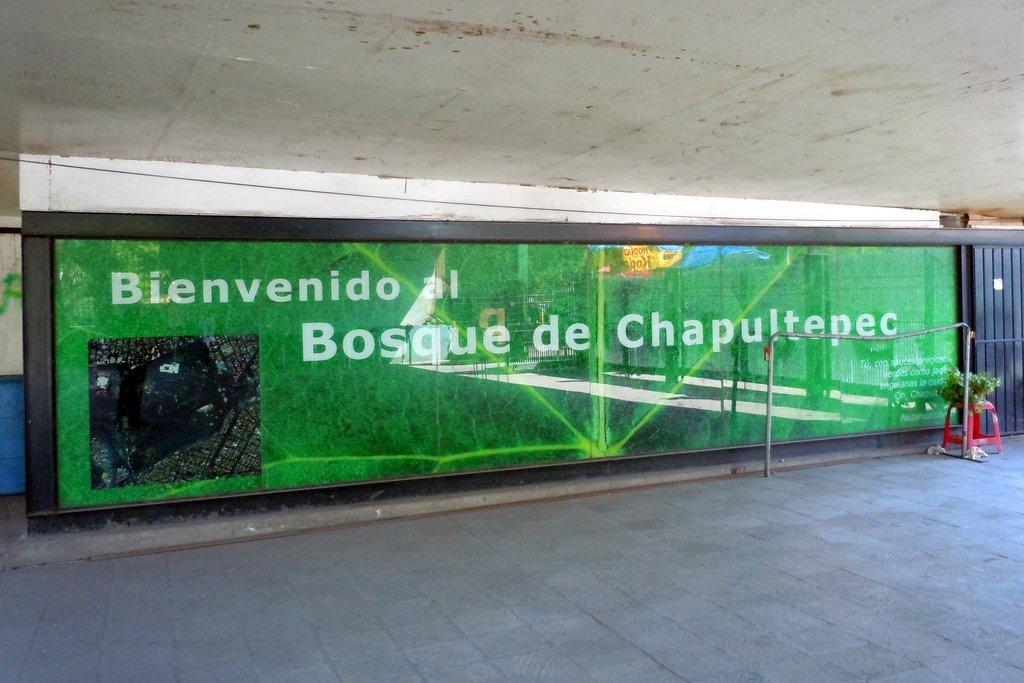What is the main object in the image? There is a name board in the image. What else can be seen in the image besides the name board? There is a pole, a plant on a stool, and a drum visible on the backside of the image. Can you describe the plant's location in the image? The plant is placed on a surface, and it is on a stool. What type of structure is visible in the image? There is a wall and a roof visible in the image. What invention is being used to breathe underwater in the image? There is no underwater scene or invention present in the image. 